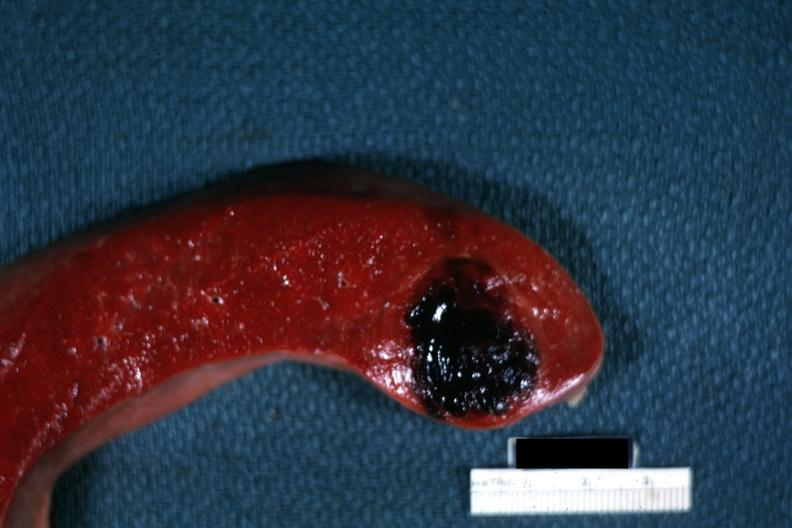s 70yof present?
Answer the question using a single word or phrase. No 